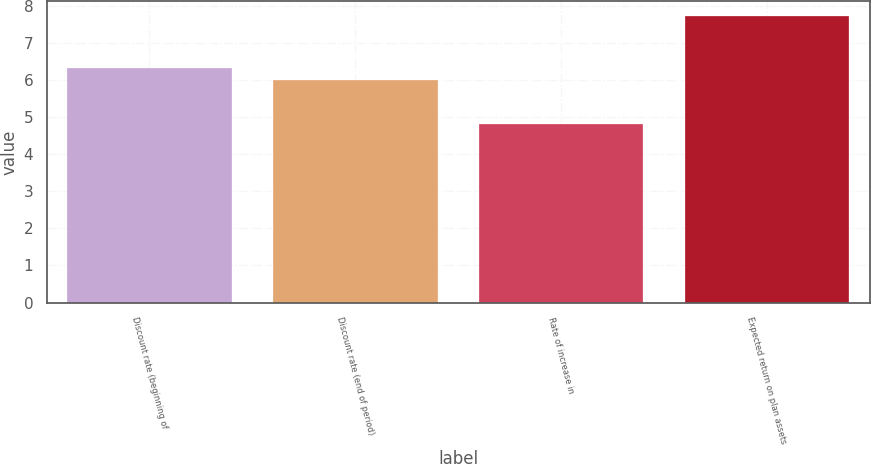Convert chart. <chart><loc_0><loc_0><loc_500><loc_500><bar_chart><fcel>Discount rate (beginning of<fcel>Discount rate (end of period)<fcel>Rate of increase in<fcel>Expected return on plan assets<nl><fcel>6.33<fcel>6<fcel>4.83<fcel>7.75<nl></chart> 